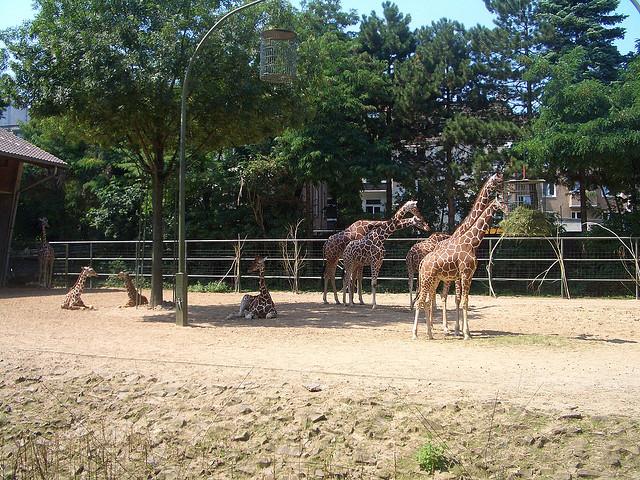Who many giraffe is there?
Quick response, please. 7. What kind of animals are in this picture?
Write a very short answer. Giraffes. Are these animals in the wild?
Give a very brief answer. No. How many giraffes are laying down?
Keep it brief. 3. 